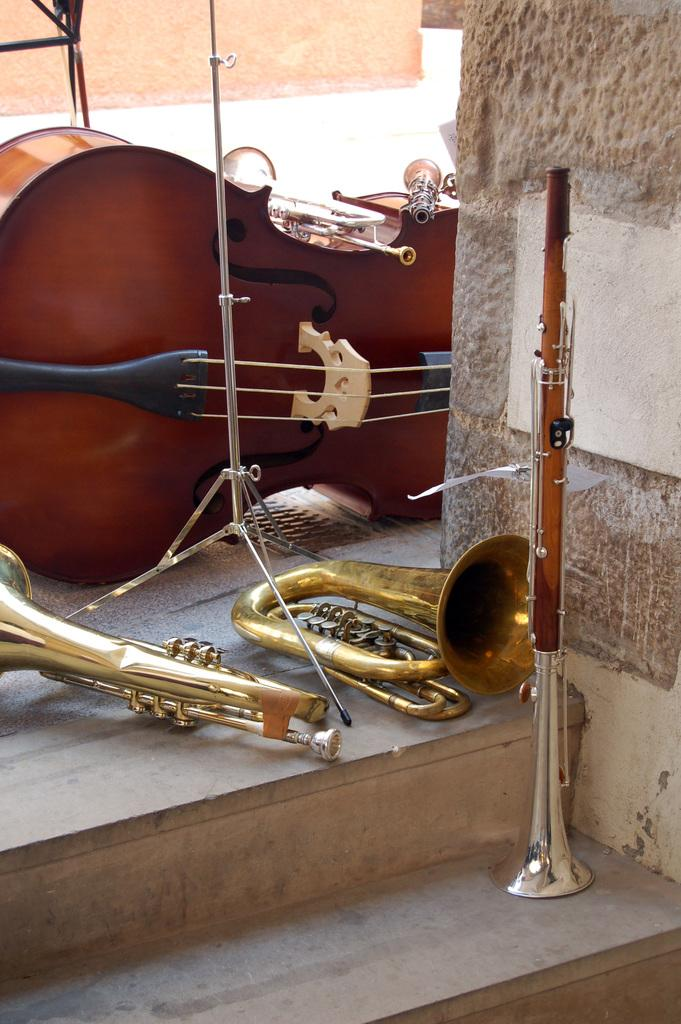What type of musical instruments can be seen in the image? There are trumpets and a guitar in the image, as well as other musical instruments. Can you describe the setting where the musical instruments are located? There is a wall and stairs in the image, which suggests a possible indoor or stage setting. How many different types of musical instruments are visible in the image? There are at least three different types of musical instruments visible in the image. What type of bird is sitting on the cup in the image? There is no bird or cup present in the image; it features musical instruments and a wall with stairs. 